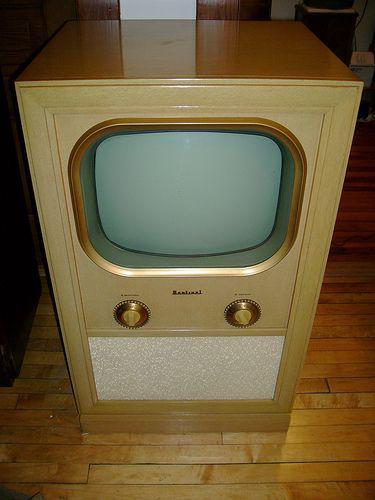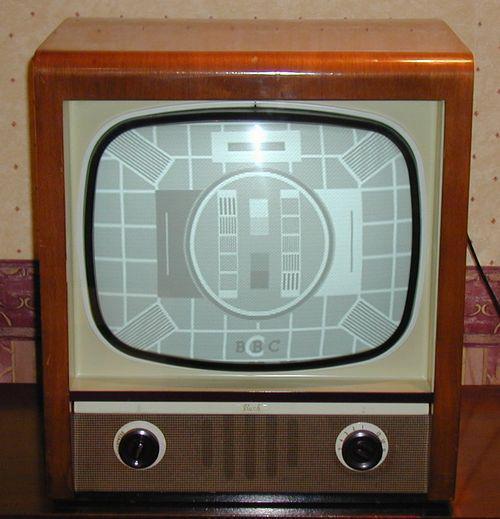The first image is the image on the left, the second image is the image on the right. For the images shown, is this caption "In at lease on image, there is a oval shaped tv screen held by wooden tv case that has three rows of brick like rectangles." true? Answer yes or no. No. The first image is the image on the left, the second image is the image on the right. Considering the images on both sides, is "The speaker under one of the television monitors shows a horizontal brick-like pattern." valid? Answer yes or no. No. 